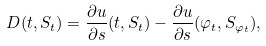<formula> <loc_0><loc_0><loc_500><loc_500>D ( t , S _ { t } ) = \frac { \partial u } { \partial s } ( t , S _ { t } ) - \frac { \partial u } { \partial s } ( \varphi _ { t } , S _ { \varphi _ { t } } ) ,</formula> 